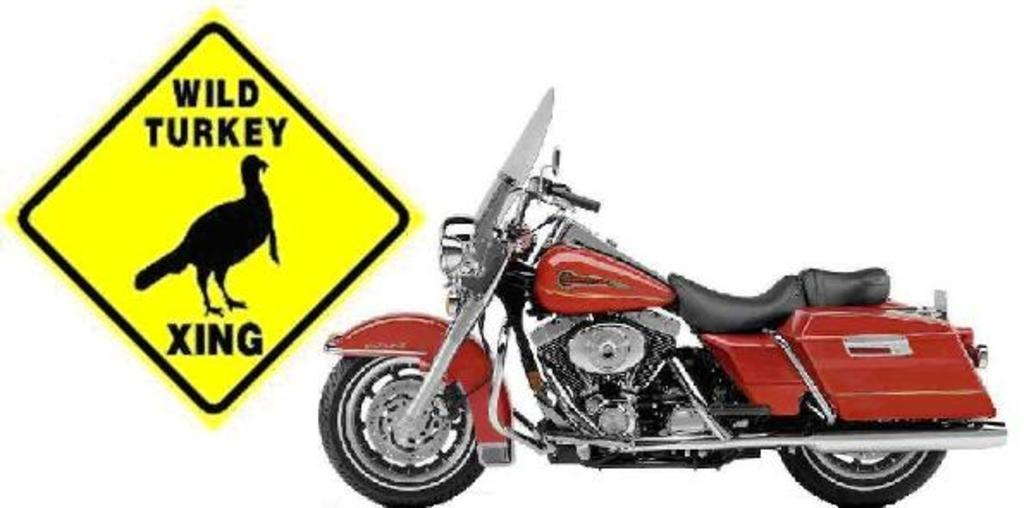What is the main object in the image? There is a bike in the image. What can be seen on the left side of the image? There is a board on the left side of the image. What is written or depicted on the board? There is text on the board, and a bird is depicted on it. How many giraffes are standing next to the bike in the image? There are no giraffes present in the image. What type of flowers can be seen growing around the bike in the image? There are no flowers present in the image. 